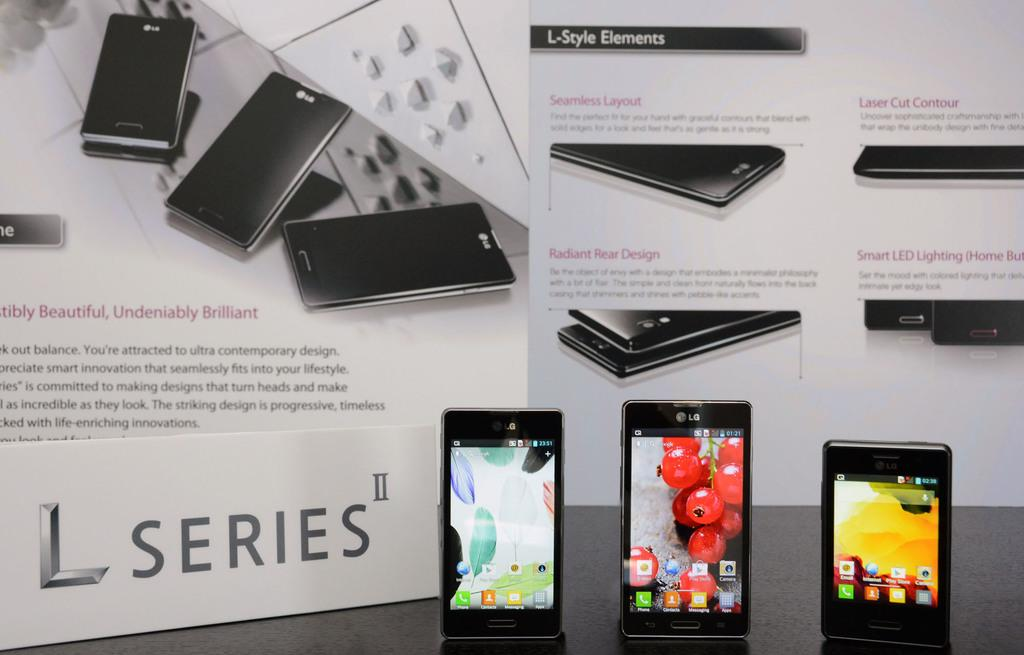Provide a one-sentence caption for the provided image. The new L series of cell phones 3 phones shown. 